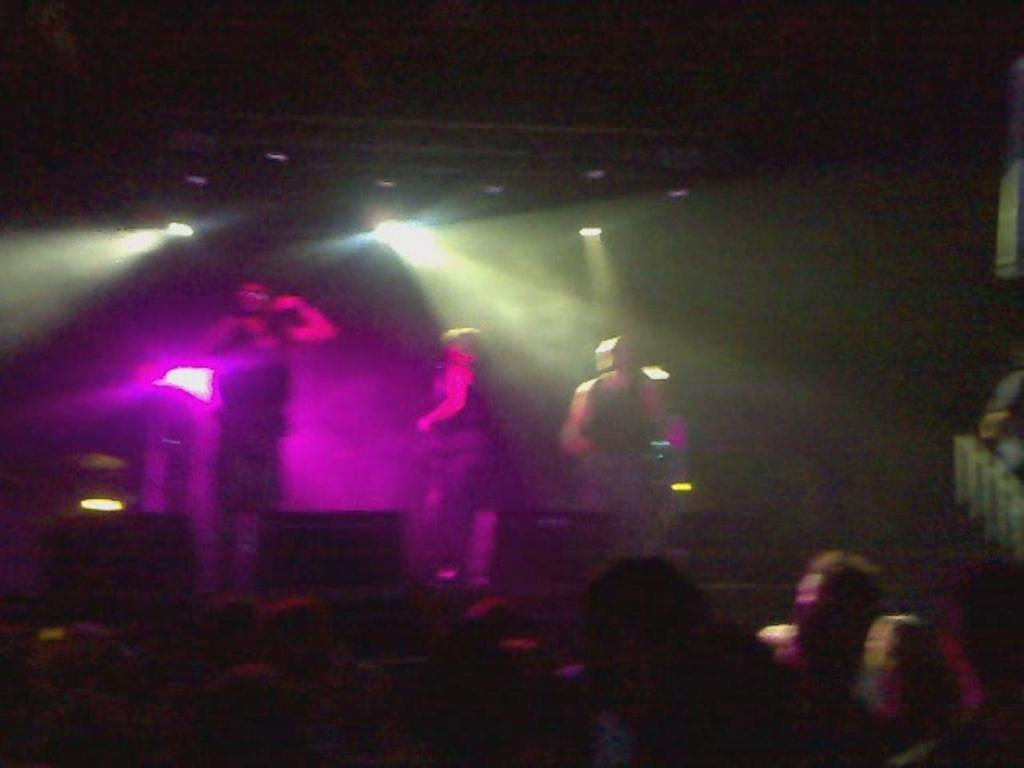What are the people in the image doing? Some people are standing, and others are sitting in the image. Can you describe the lighting in the image? There is a pink color light in the image. How many ducks are visible in the image? There are no ducks present in the image. What type of pencil is being used by the people in the image? There is no pencil visible in the image. 